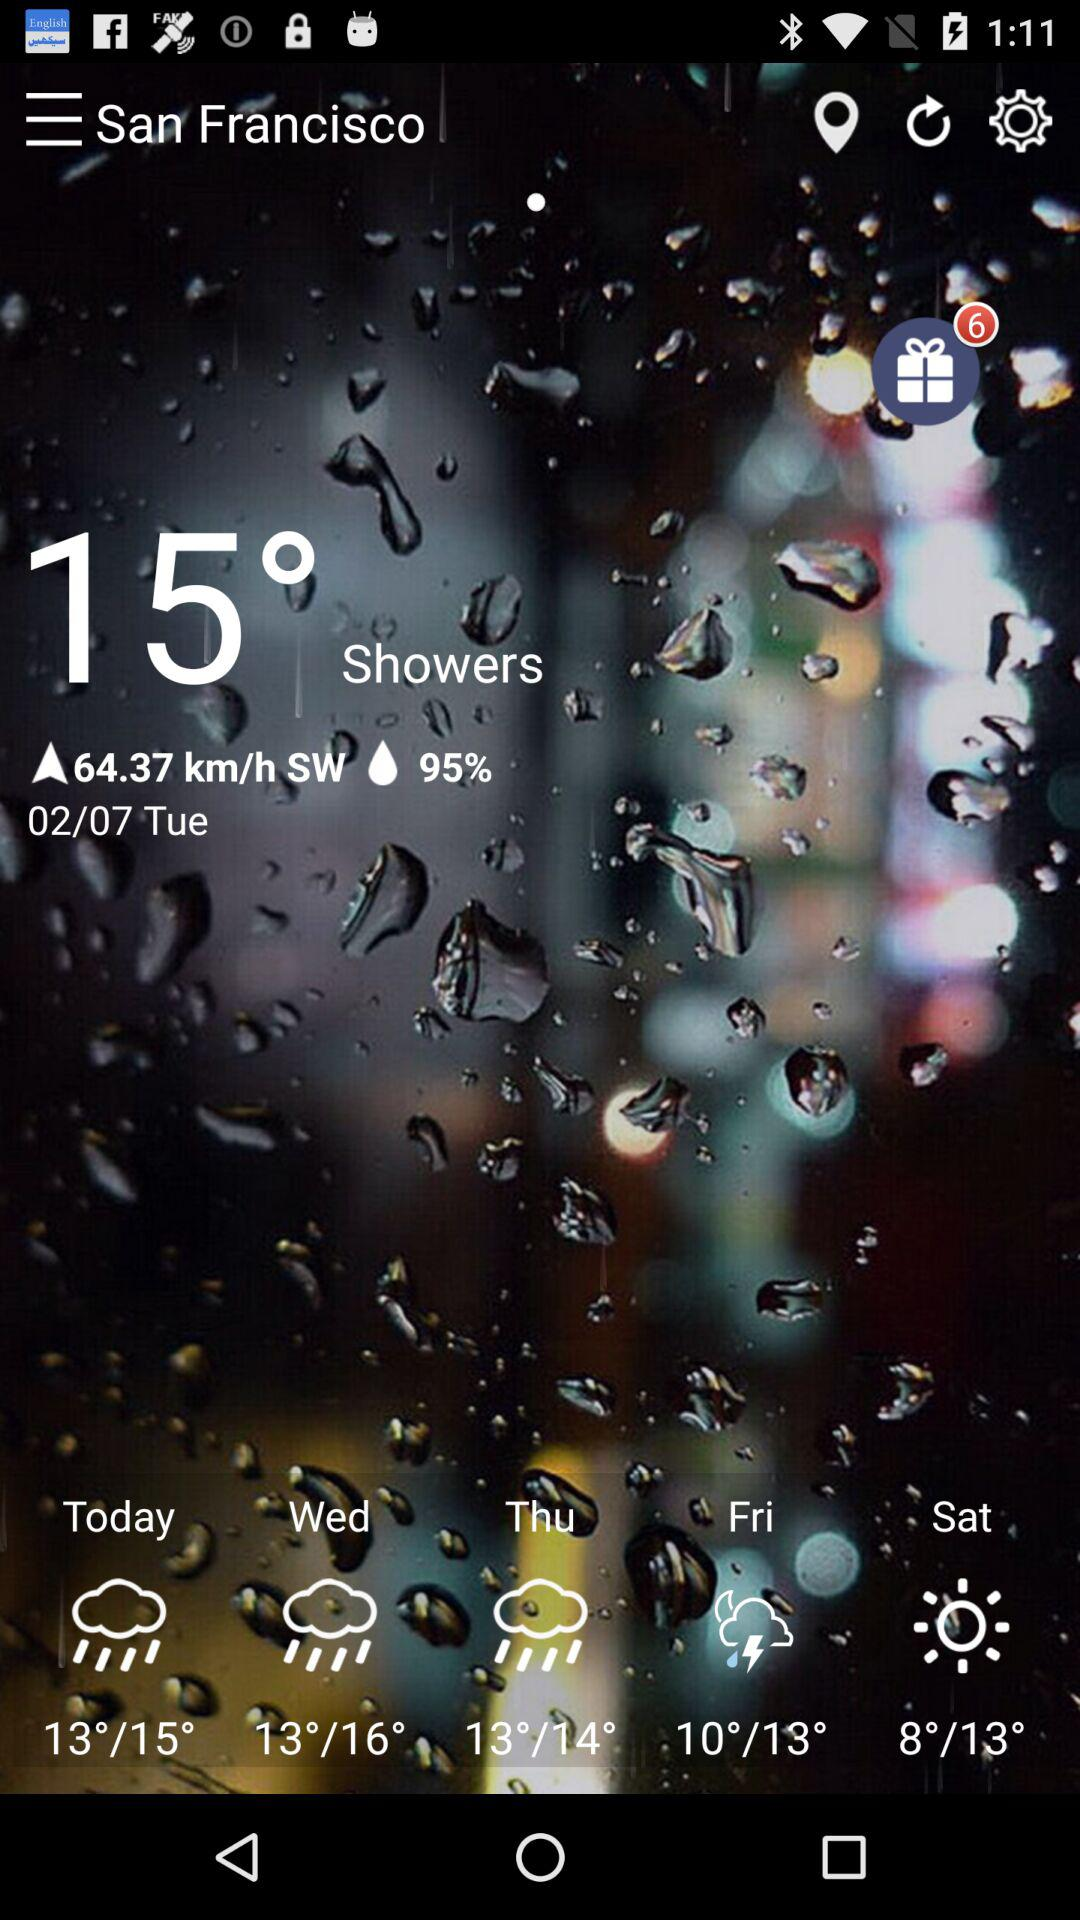What is the date? The date is Tuesday, February 7. 